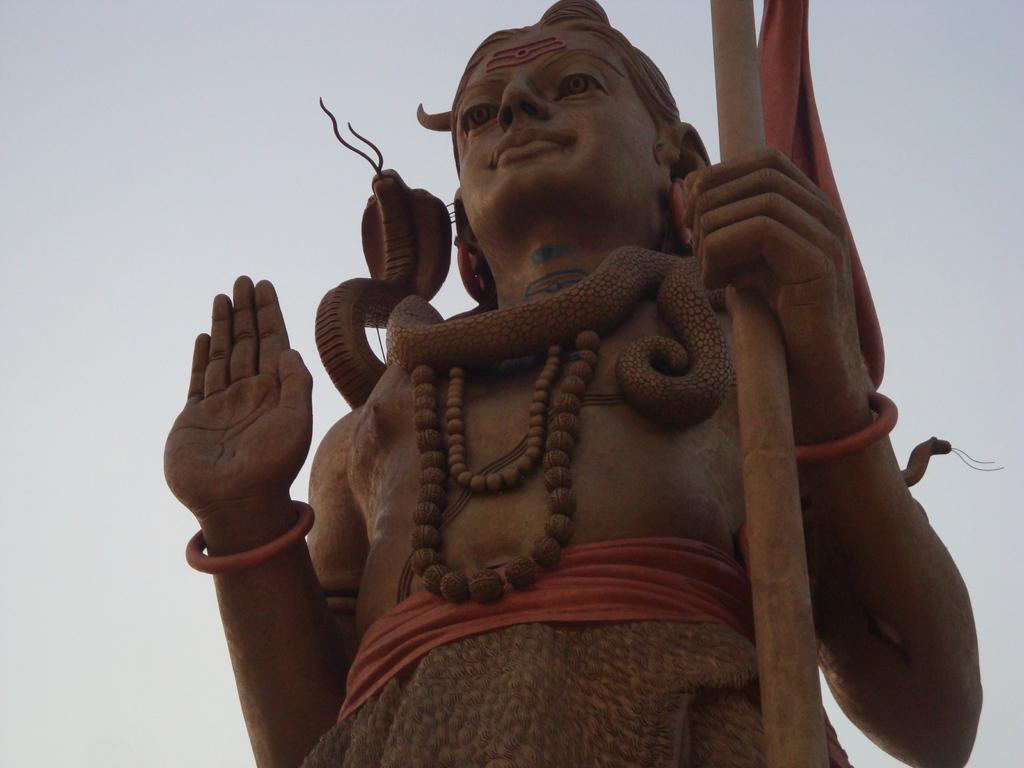What is the main subject in the image? There is a statue in the image. What is unique about the statue? A snake is wrapped around the neck of the statue. What can be seen in the background of the image? The sky is visible in the background of the image. What type of insurance policy is being advertised by the statue in the image? There is no insurance policy being advertised by the statue in the image. The statue is simply a statue with a snake wrapped around its neck, and there is no indication of any advertisement or promotion. 